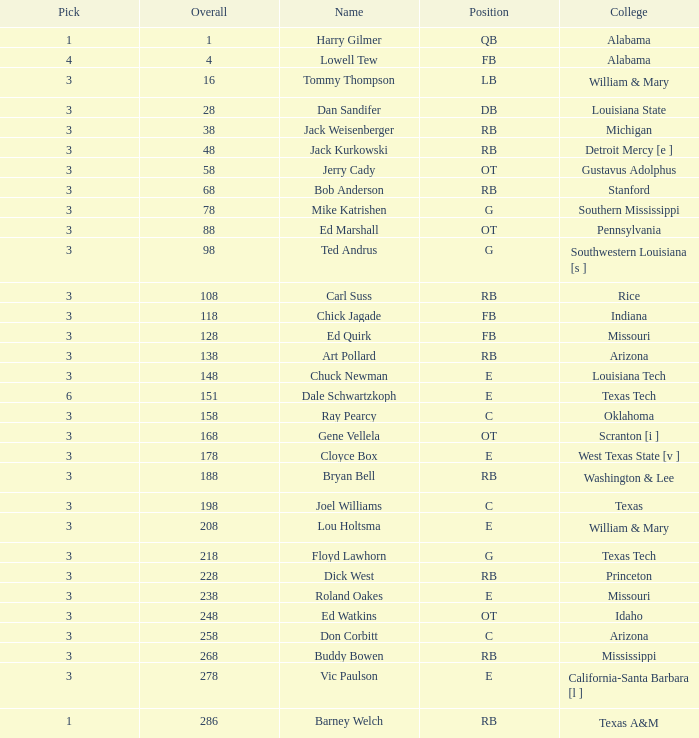How much cumulative has a name of bob anderson? 1.0. 